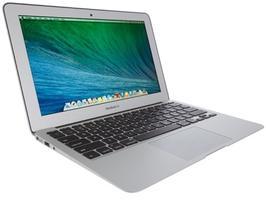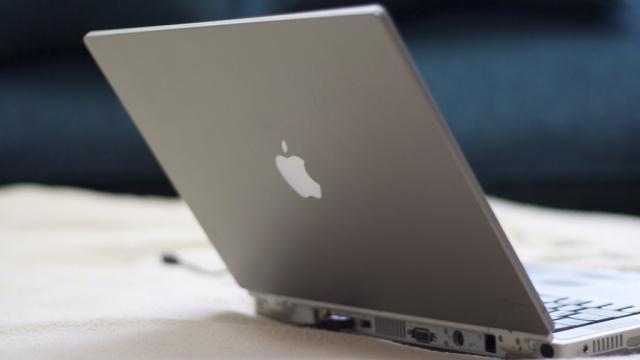The first image is the image on the left, the second image is the image on the right. For the images displayed, is the sentence "There is only one laptop screen visible out of two laptops." factually correct? Answer yes or no. Yes. The first image is the image on the left, the second image is the image on the right. Examine the images to the left and right. Is the description "All laptops are at least partly open, but only one laptop is displayed with its screen visible." accurate? Answer yes or no. Yes. 